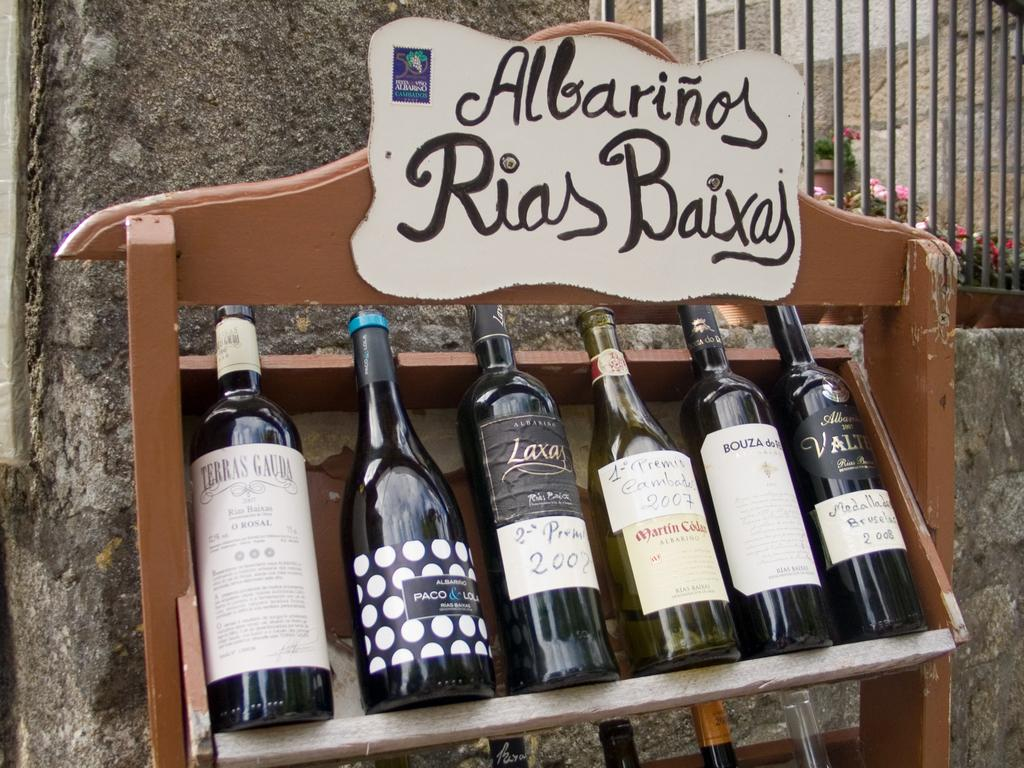<image>
Write a terse but informative summary of the picture. Several bottles of wine sit on a rack that says "Albarinos Rias Baixas". 